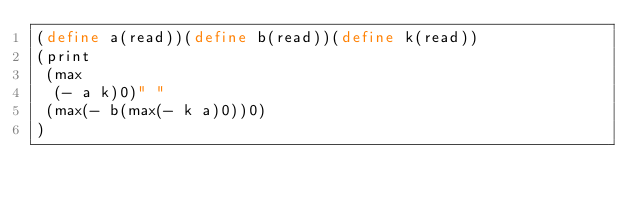<code> <loc_0><loc_0><loc_500><loc_500><_Scheme_>(define a(read))(define b(read))(define k(read))
(print
 (max
  (- a k)0)" "
 (max(- b(max(- k a)0))0)
)</code> 